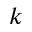<formula> <loc_0><loc_0><loc_500><loc_500>k</formula> 